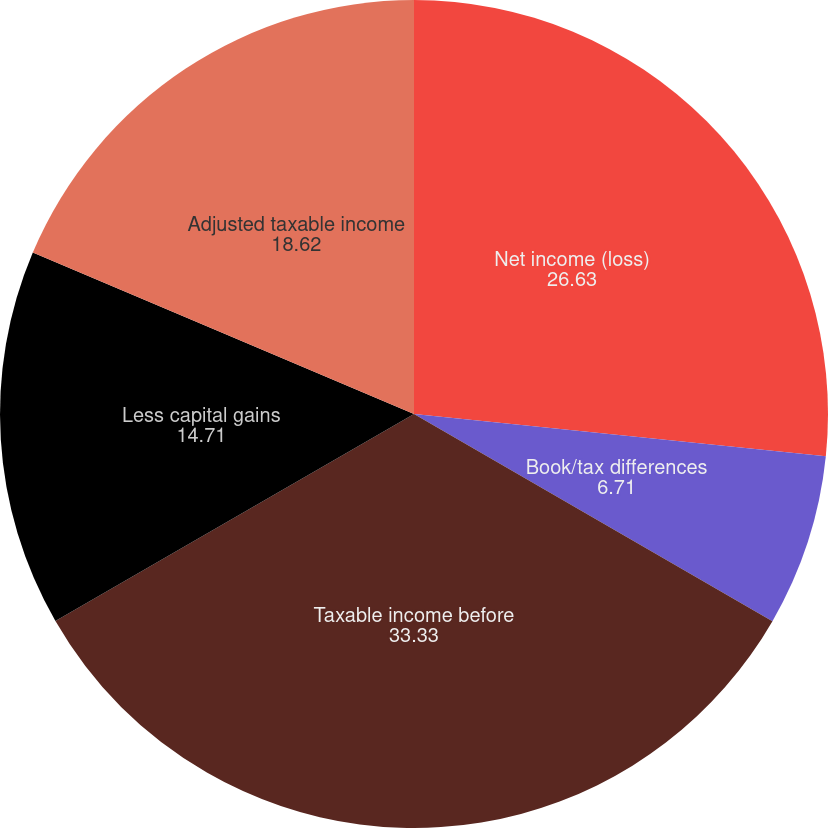<chart> <loc_0><loc_0><loc_500><loc_500><pie_chart><fcel>Net income (loss)<fcel>Book/tax differences<fcel>Taxable income before<fcel>Less capital gains<fcel>Adjusted taxable income<nl><fcel>26.63%<fcel>6.71%<fcel>33.33%<fcel>14.71%<fcel>18.62%<nl></chart> 